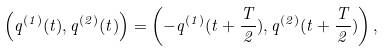<formula> <loc_0><loc_0><loc_500><loc_500>\left ( q ^ { ( 1 ) } ( t ) , q ^ { ( 2 ) } ( t ) \right ) = \left ( - q ^ { ( 1 ) } ( t + \frac { T } { 2 } ) , q ^ { ( 2 ) } ( t + \frac { T } { 2 } ) \right ) ,</formula> 